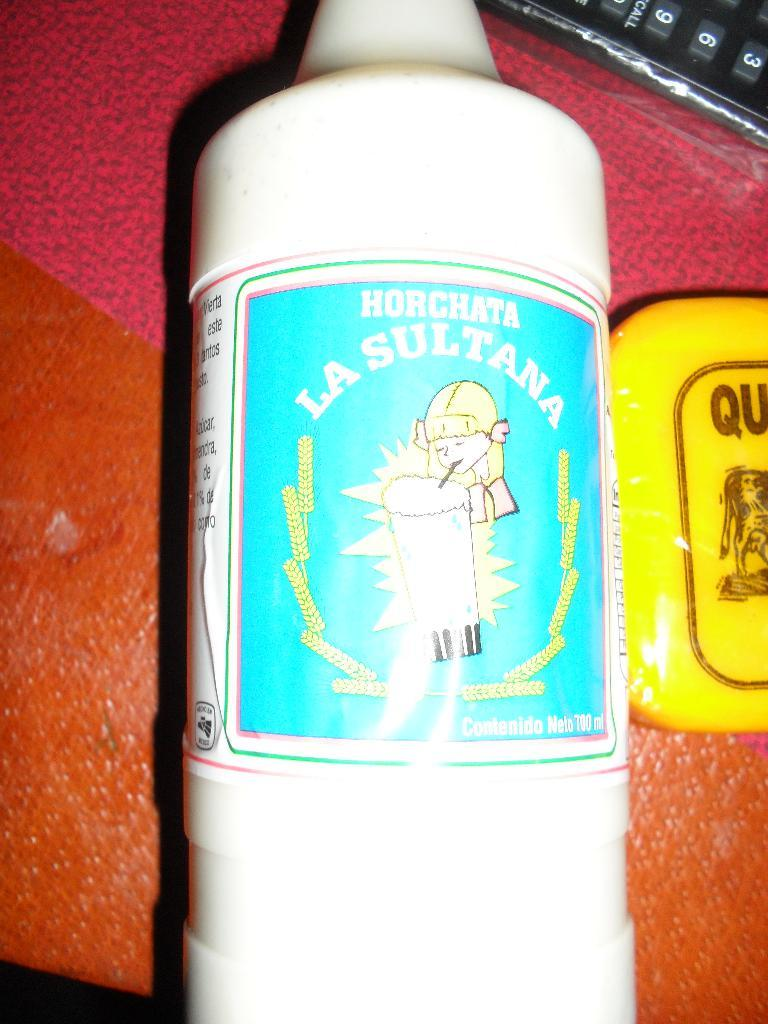<image>
Provide a brief description of the given image. A bottle of Horchata with an image of a girl drinking it. 